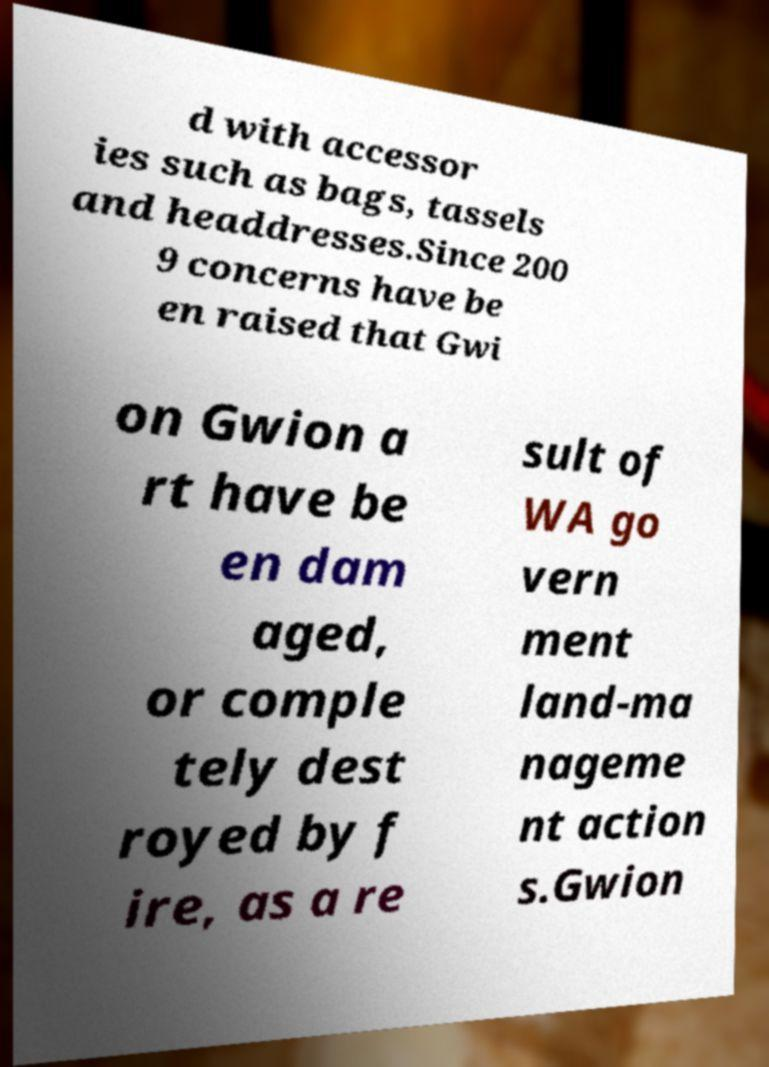I need the written content from this picture converted into text. Can you do that? d with accessor ies such as bags, tassels and headdresses.Since 200 9 concerns have be en raised that Gwi on Gwion a rt have be en dam aged, or comple tely dest royed by f ire, as a re sult of WA go vern ment land-ma nageme nt action s.Gwion 